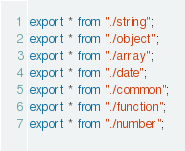Convert code to text. <code><loc_0><loc_0><loc_500><loc_500><_TypeScript_>export * from "./string";
export * from "./object";
export * from "./array";
export * from "./date";
export * from "./common";
export * from "./function";
export * from "./number";
</code> 